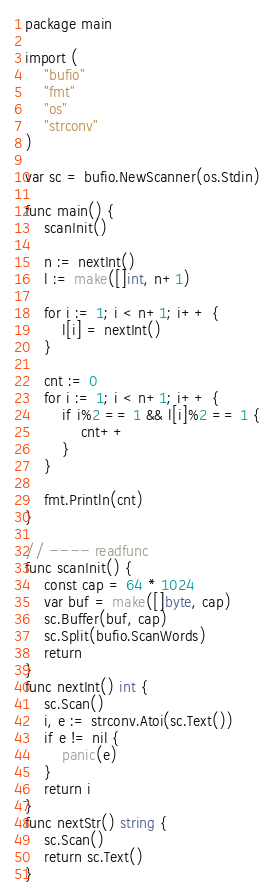Convert code to text. <code><loc_0><loc_0><loc_500><loc_500><_Go_>package main

import (
	"bufio"
	"fmt"
	"os"
	"strconv"
)

var sc = bufio.NewScanner(os.Stdin)

func main() {
	scanInit()

	n := nextInt()
	l := make([]int, n+1)

	for i := 1; i < n+1; i++ {
		l[i] = nextInt()
	}

	cnt := 0
	for i := 1; i < n+1; i++ {
		if i%2 == 1 && l[i]%2 == 1 {
			cnt++
		}
	}

	fmt.Println(cnt)
}

// ---- readfunc
func scanInit() {
	const cap = 64 * 1024
	var buf = make([]byte, cap)
	sc.Buffer(buf, cap)
	sc.Split(bufio.ScanWords)
	return
}
func nextInt() int {
	sc.Scan()
	i, e := strconv.Atoi(sc.Text())
	if e != nil {
		panic(e)
	}
	return i
}
func nextStr() string {
	sc.Scan()
	return sc.Text()
}
</code> 